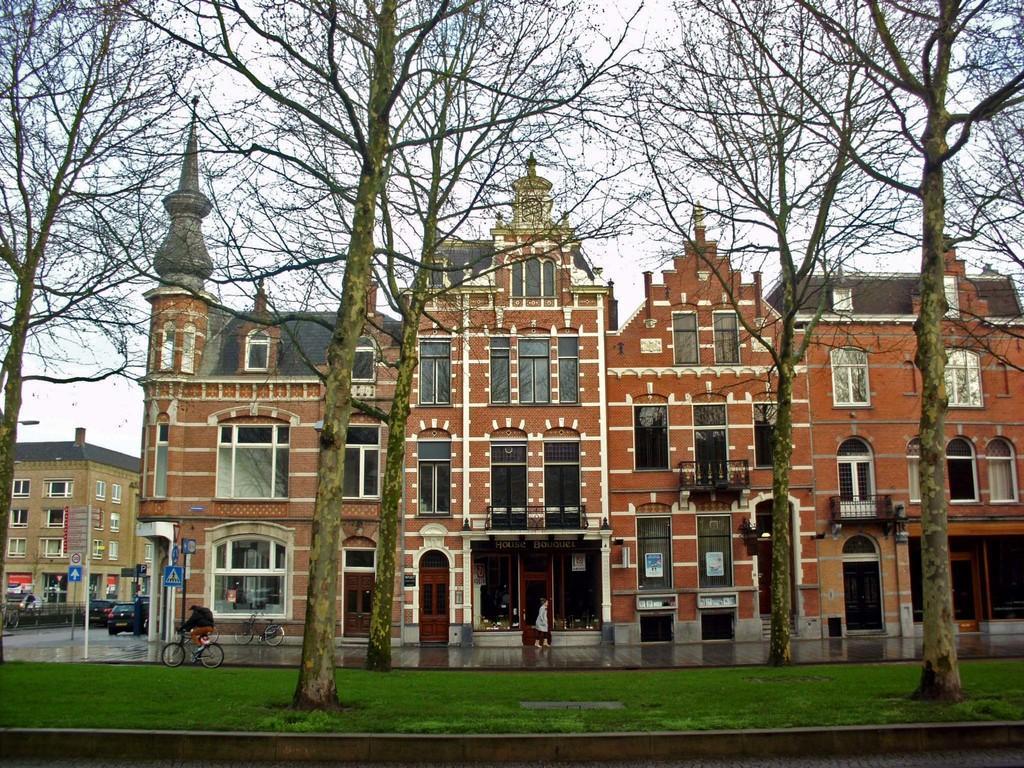Can you describe this image briefly? This image consists of a building in brown color. At the bottom, there is green grass. In the front, we can see many trees. On the left, there is a person riding bicycle. On the left, there is a building and a car. 